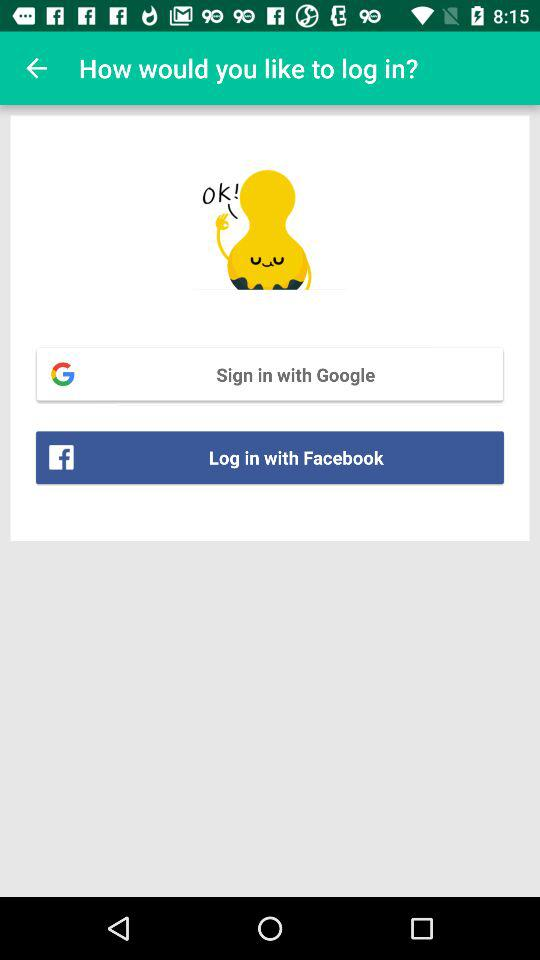How can we sign in? You can sign in with "Google" and "Facebook". 